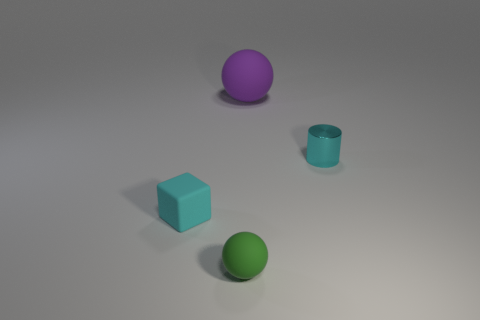There is a ball that is right of the ball that is in front of the tiny cyan object that is on the right side of the large purple matte object; what is its size?
Give a very brief answer. Large. Is there a ball that has the same material as the tiny block?
Your answer should be very brief. Yes. What is the shape of the big purple object?
Provide a succinct answer. Sphere. The small sphere that is made of the same material as the tiny block is what color?
Your answer should be compact. Green. What number of purple objects are tiny metallic cylinders or big matte objects?
Give a very brief answer. 1. Are there more tiny cyan cubes than rubber spheres?
Keep it short and to the point. No. What number of things are objects behind the green thing or tiny things that are to the right of the green matte object?
Your response must be concise. 3. The rubber object that is the same size as the block is what color?
Offer a terse response. Green. Do the small cyan cylinder and the green sphere have the same material?
Your answer should be compact. No. What is the material of the sphere that is behind the small rubber thing to the left of the tiny green sphere?
Your answer should be very brief. Rubber. 